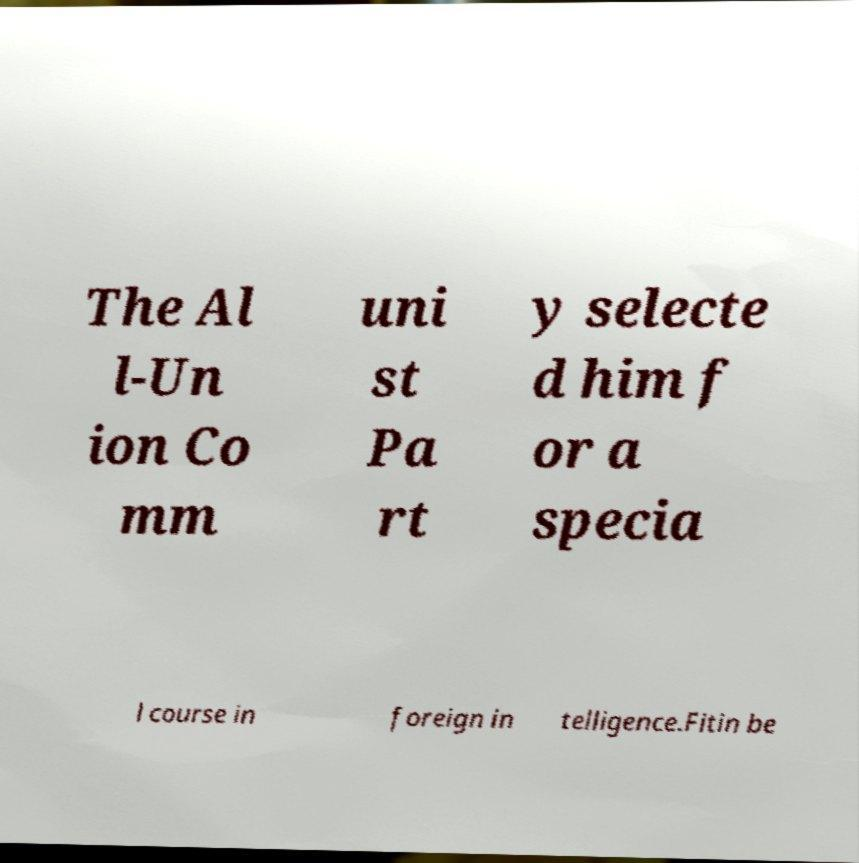Could you assist in decoding the text presented in this image and type it out clearly? The Al l-Un ion Co mm uni st Pa rt y selecte d him f or a specia l course in foreign in telligence.Fitin be 